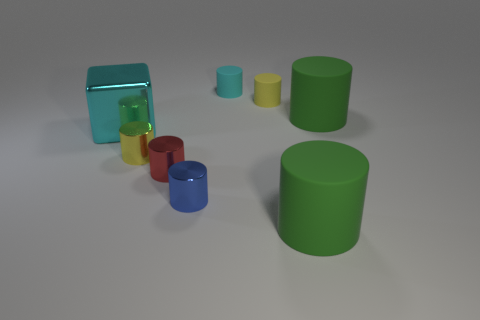Subtract 2 cylinders. How many cylinders are left? 5 Subtract all green cylinders. How many cylinders are left? 5 Subtract all red cylinders. How many cylinders are left? 6 Subtract all gray cylinders. Subtract all brown balls. How many cylinders are left? 7 Add 1 large cyan shiny cubes. How many objects exist? 9 Subtract all cylinders. How many objects are left? 1 Subtract all large green matte objects. Subtract all yellow metallic cylinders. How many objects are left? 5 Add 3 metallic cylinders. How many metallic cylinders are left? 6 Add 7 purple metallic cubes. How many purple metallic cubes exist? 7 Subtract 0 purple cubes. How many objects are left? 8 